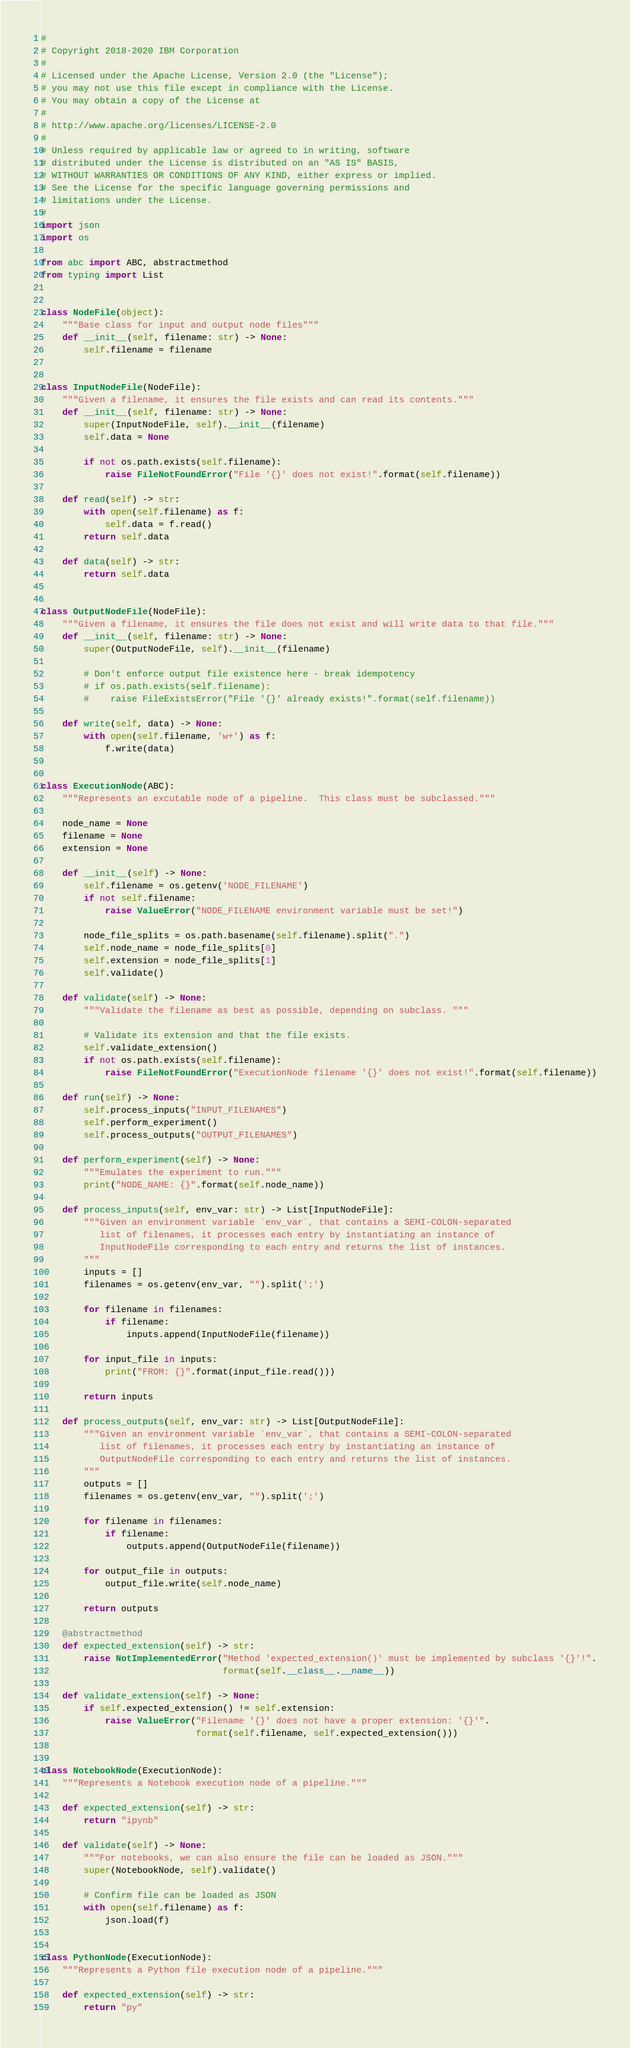Convert code to text. <code><loc_0><loc_0><loc_500><loc_500><_Python_>#
# Copyright 2018-2020 IBM Corporation
#
# Licensed under the Apache License, Version 2.0 (the "License");
# you may not use this file except in compliance with the License.
# You may obtain a copy of the License at
#
# http://www.apache.org/licenses/LICENSE-2.0
#
# Unless required by applicable law or agreed to in writing, software
# distributed under the License is distributed on an "AS IS" BASIS,
# WITHOUT WARRANTIES OR CONDITIONS OF ANY KIND, either express or implied.
# See the License for the specific language governing permissions and
# limitations under the License.
#
import json
import os

from abc import ABC, abstractmethod
from typing import List


class NodeFile(object):
    """Base class for input and output node files"""
    def __init__(self, filename: str) -> None:
        self.filename = filename


class InputNodeFile(NodeFile):
    """Given a filename, it ensures the file exists and can read its contents."""
    def __init__(self, filename: str) -> None:
        super(InputNodeFile, self).__init__(filename)
        self.data = None

        if not os.path.exists(self.filename):
            raise FileNotFoundError("File '{}' does not exist!".format(self.filename))

    def read(self) -> str:
        with open(self.filename) as f:
            self.data = f.read()
        return self.data

    def data(self) -> str:
        return self.data


class OutputNodeFile(NodeFile):
    """Given a filename, it ensures the file does not exist and will write data to that file."""
    def __init__(self, filename: str) -> None:
        super(OutputNodeFile, self).__init__(filename)

        # Don't enforce output file existence here - break idempotency
        # if os.path.exists(self.filename):
        #    raise FileExistsError("File '{}' already exists!".format(self.filename))

    def write(self, data) -> None:
        with open(self.filename, 'w+') as f:
            f.write(data)


class ExecutionNode(ABC):
    """Represents an excutable node of a pipeline.  This class must be subclassed."""

    node_name = None
    filename = None
    extension = None

    def __init__(self) -> None:
        self.filename = os.getenv('NODE_FILENAME')
        if not self.filename:
            raise ValueError("NODE_FILENAME environment variable must be set!")

        node_file_splits = os.path.basename(self.filename).split(".")
        self.node_name = node_file_splits[0]
        self.extension = node_file_splits[1]
        self.validate()

    def validate(self) -> None:
        """Validate the filename as best as possible, depending on subclass. """

        # Validate its extension and that the file exists.
        self.validate_extension()
        if not os.path.exists(self.filename):
            raise FileNotFoundError("ExecutionNode filename '{}' does not exist!".format(self.filename))

    def run(self) -> None:
        self.process_inputs("INPUT_FILENAMES")
        self.perform_experiment()
        self.process_outputs("OUTPUT_FILENAMES")

    def perform_experiment(self) -> None:
        """Emulates the experiment to run."""
        print("NODE_NAME: {}".format(self.node_name))

    def process_inputs(self, env_var: str) -> List[InputNodeFile]:
        """Given an environment variable `env_var`, that contains a SEMI-COLON-separated
           list of filenames, it processes each entry by instantiating an instance of
           InputNodeFile corresponding to each entry and returns the list of instances.
        """
        inputs = []
        filenames = os.getenv(env_var, "").split(';')

        for filename in filenames:
            if filename:
                inputs.append(InputNodeFile(filename))

        for input_file in inputs:
            print("FROM: {}".format(input_file.read()))

        return inputs

    def process_outputs(self, env_var: str) -> List[OutputNodeFile]:
        """Given an environment variable `env_var`, that contains a SEMI-COLON-separated
           list of filenames, it processes each entry by instantiating an instance of
           OutputNodeFile corresponding to each entry and returns the list of instances.
        """
        outputs = []
        filenames = os.getenv(env_var, "").split(';')

        for filename in filenames:
            if filename:
                outputs.append(OutputNodeFile(filename))

        for output_file in outputs:
            output_file.write(self.node_name)

        return outputs

    @abstractmethod
    def expected_extension(self) -> str:
        raise NotImplementedError("Method 'expected_extension()' must be implemented by subclass '{}'!".
                                  format(self.__class__.__name__))

    def validate_extension(self) -> None:
        if self.expected_extension() != self.extension:
            raise ValueError("Filename '{}' does not have a proper extension: '{}'".
                             format(self.filename, self.expected_extension()))


class NotebookNode(ExecutionNode):
    """Represents a Notebook execution node of a pipeline."""

    def expected_extension(self) -> str:
        return "ipynb"

    def validate(self) -> None:
        """For notebooks, we can also ensure the file can be loaded as JSON."""
        super(NotebookNode, self).validate()

        # Confirm file can be loaded as JSON
        with open(self.filename) as f:
            json.load(f)


class PythonNode(ExecutionNode):
    """Represents a Python file execution node of a pipeline."""

    def expected_extension(self) -> str:
        return "py"
</code> 